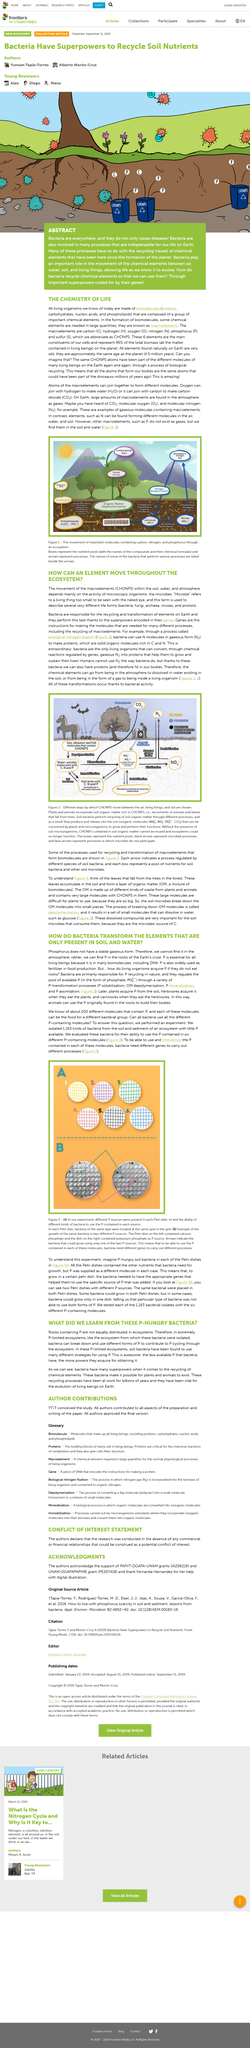Draw attention to some important aspects in this diagram. P is essential for all living beings because it is found in numerous biomolecules, including DNA, which are critical for the functioning and survival of all living organisms. Microbes cannot be seen with the naked eye, as they are too small to be visible to the human eye alone. P is used in food production, specifically as a fertilizer. I declare that CHONPS, consisting of carbon, hydrogen, oxygen, nitrogen, phosphorus, and sulfur, are moving through various environments including soil, water, and atmosphere. Rocks containing P are not equally distributed in ecosystems, as evidenced by the fact that the answer to the question "Are rocks containing P equally distributed in ecosystems?" is "No. 